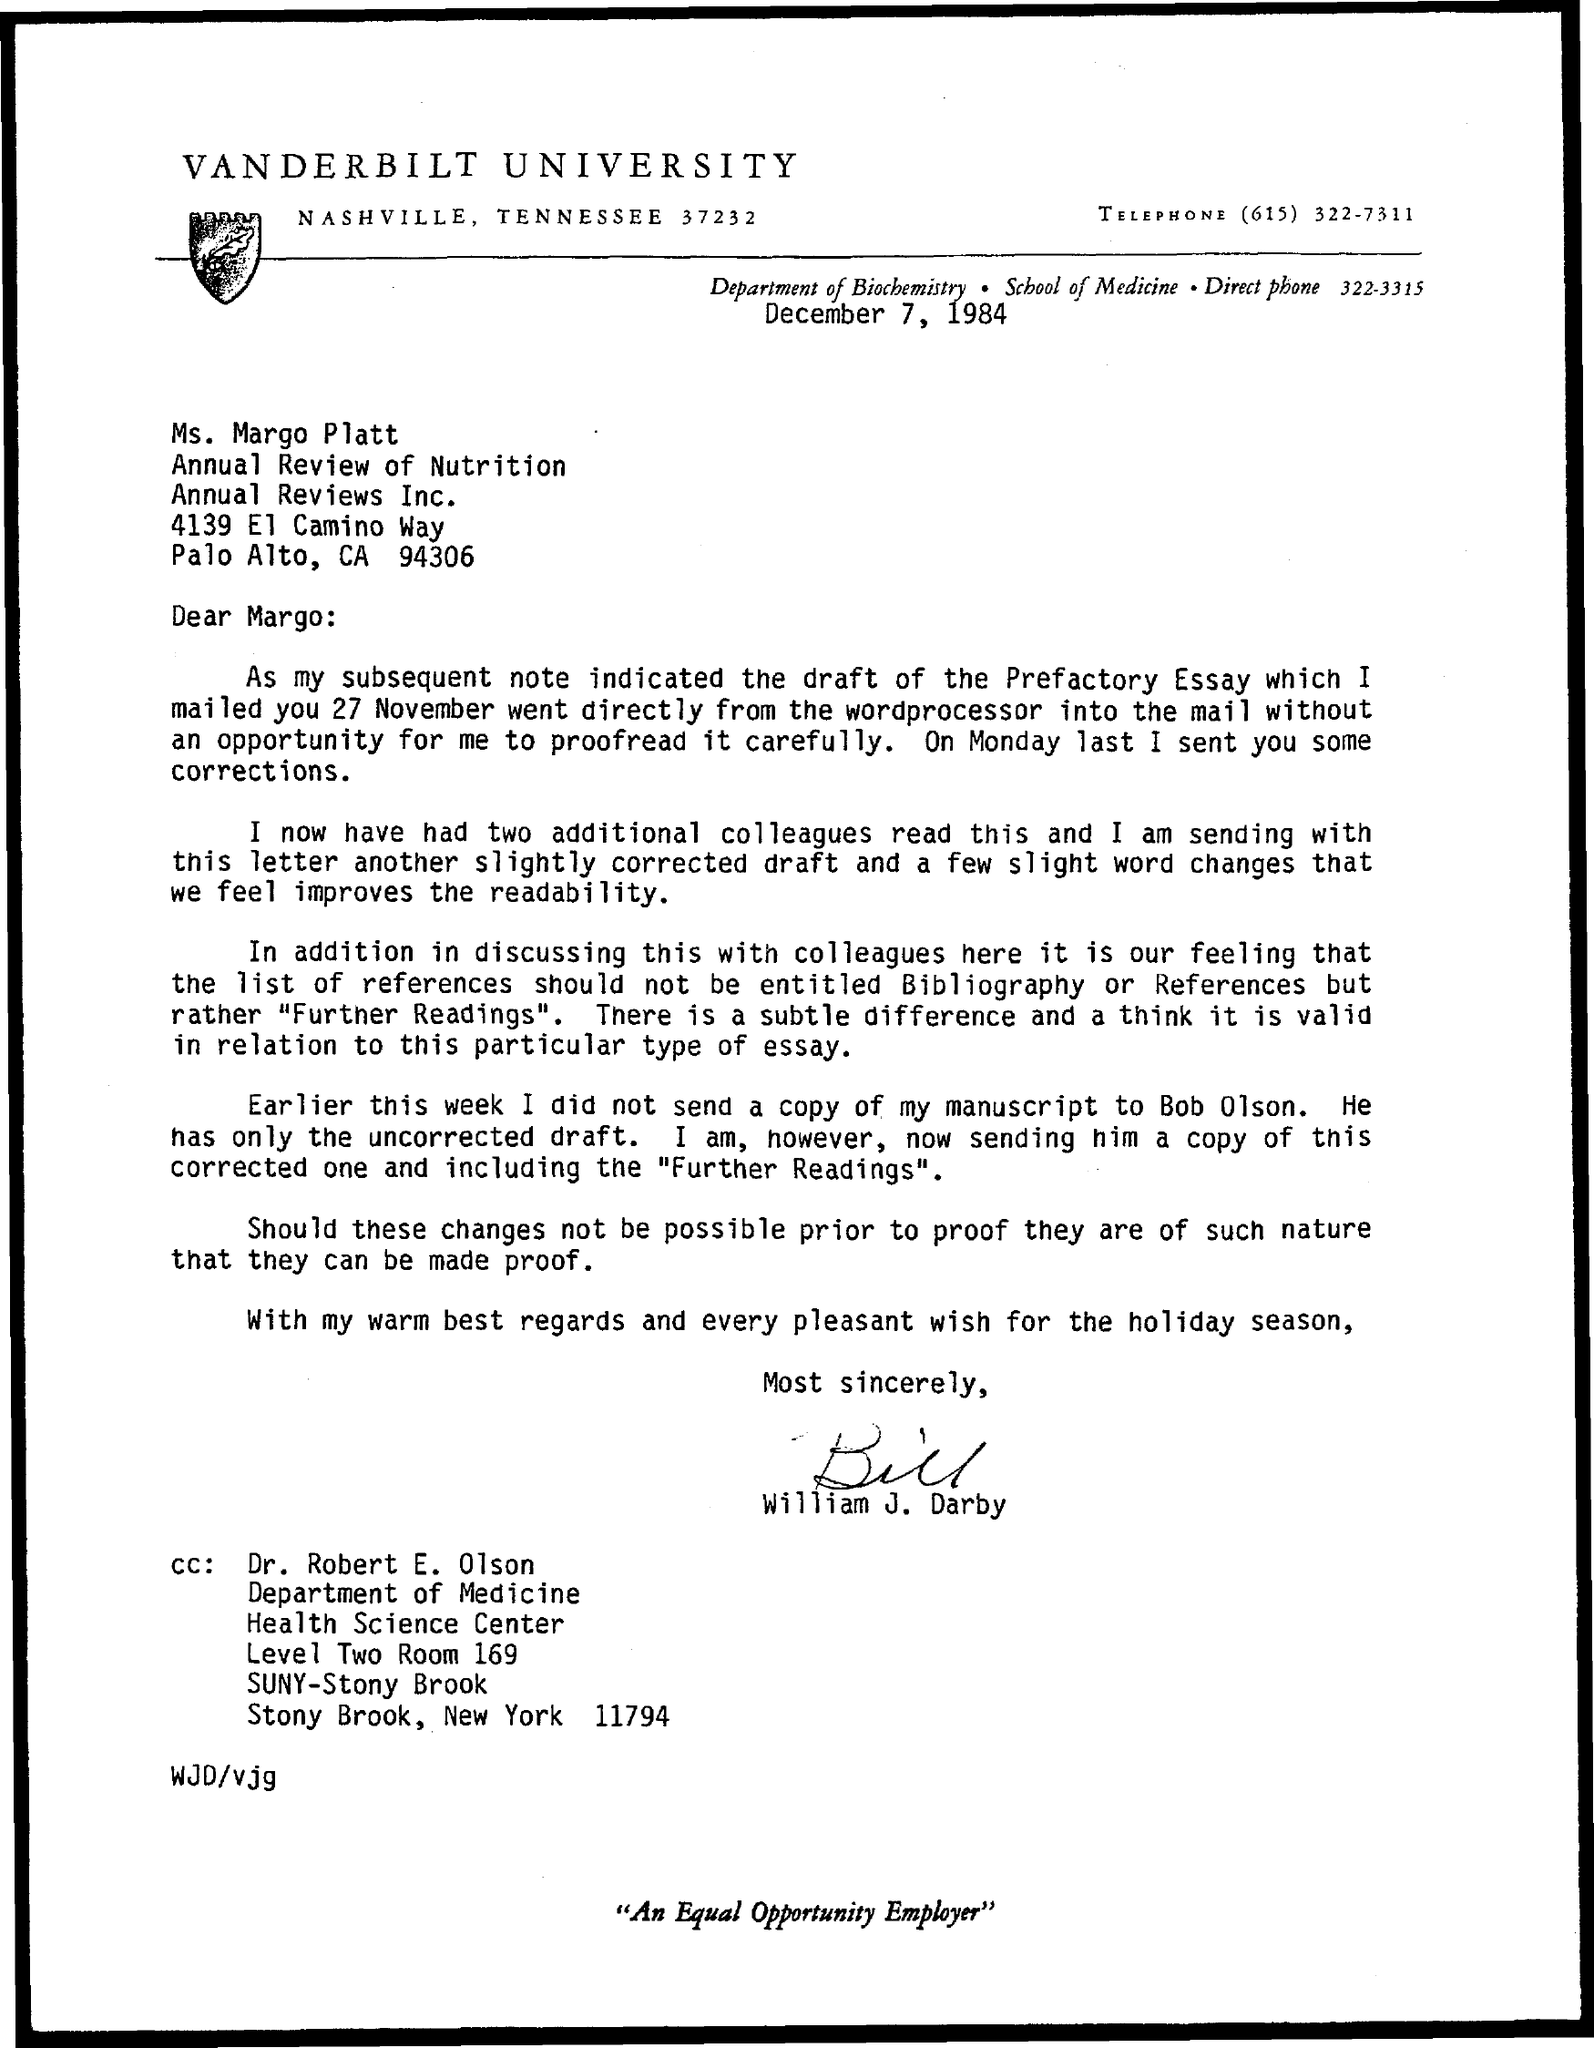When is the Letter Issued?
Your response must be concise. December 7, 1984. To Whom the Letter is Issued?
Ensure brevity in your answer.  Ms. Margo Platt. 